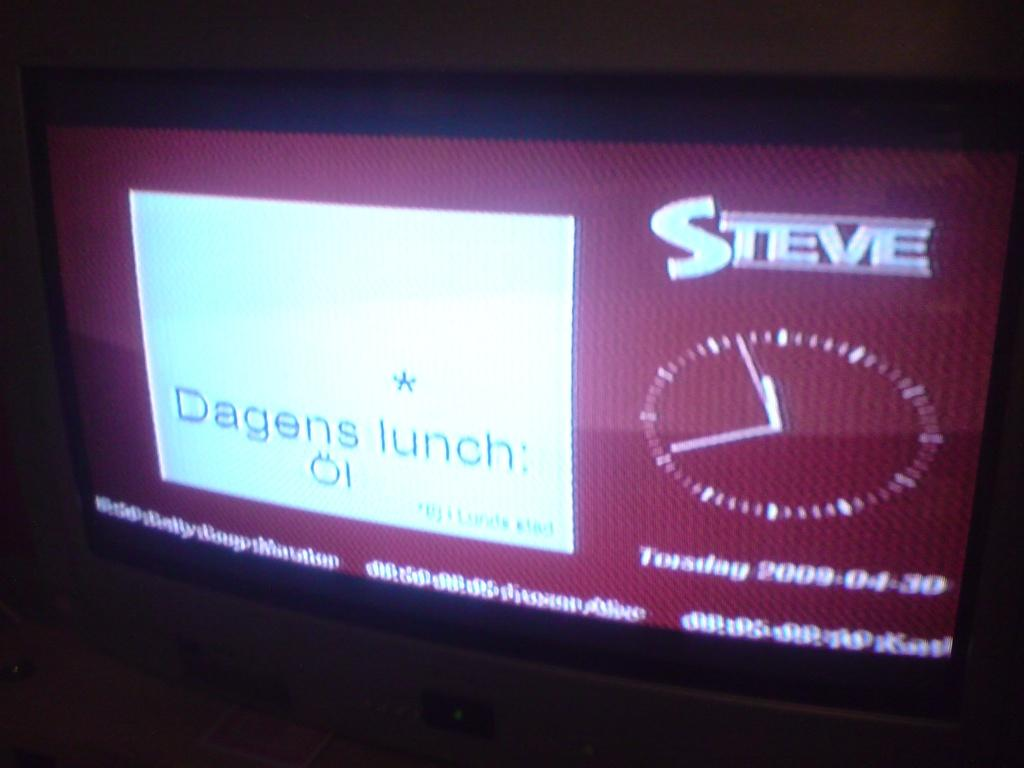Provide a one-sentence caption for the provided image. A screen that says Dagens lunch  and Steve on it. 